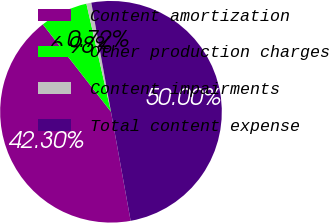Convert chart. <chart><loc_0><loc_0><loc_500><loc_500><pie_chart><fcel>Content amortization<fcel>Other production charges<fcel>Content impairments<fcel>Total content expense<nl><fcel>42.3%<fcel>6.98%<fcel>0.72%<fcel>50.0%<nl></chart> 